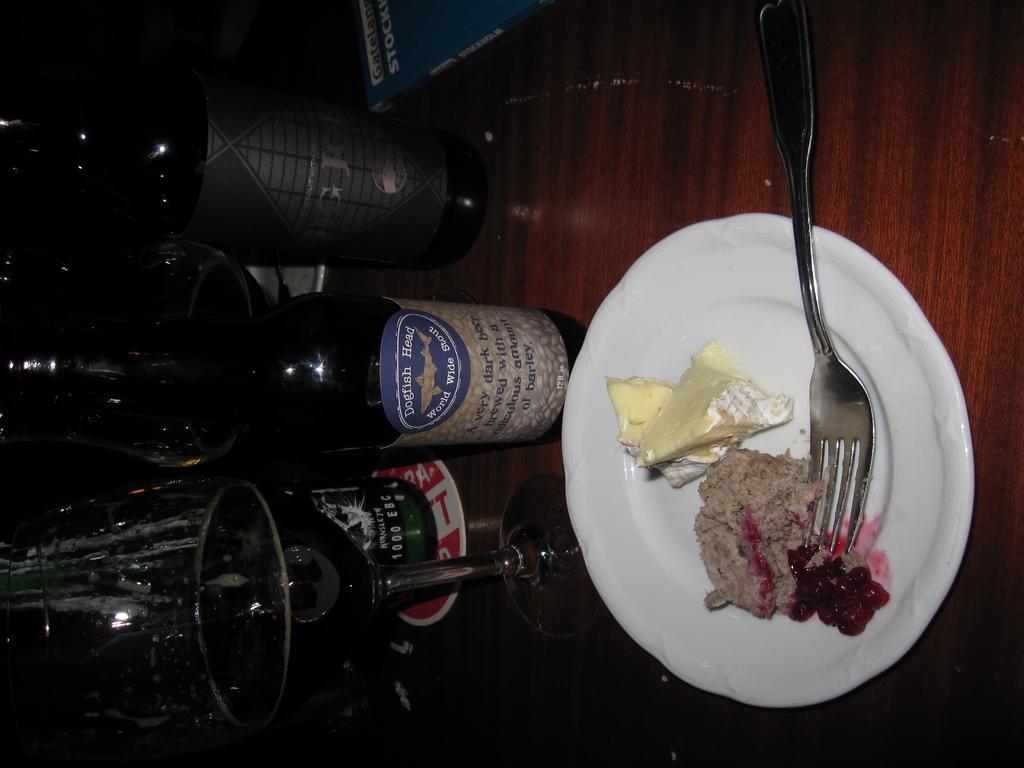Can you describe this image briefly? In this image there are bottles, glass, plate and food on the plate. These all things are kept on these wooden table. 